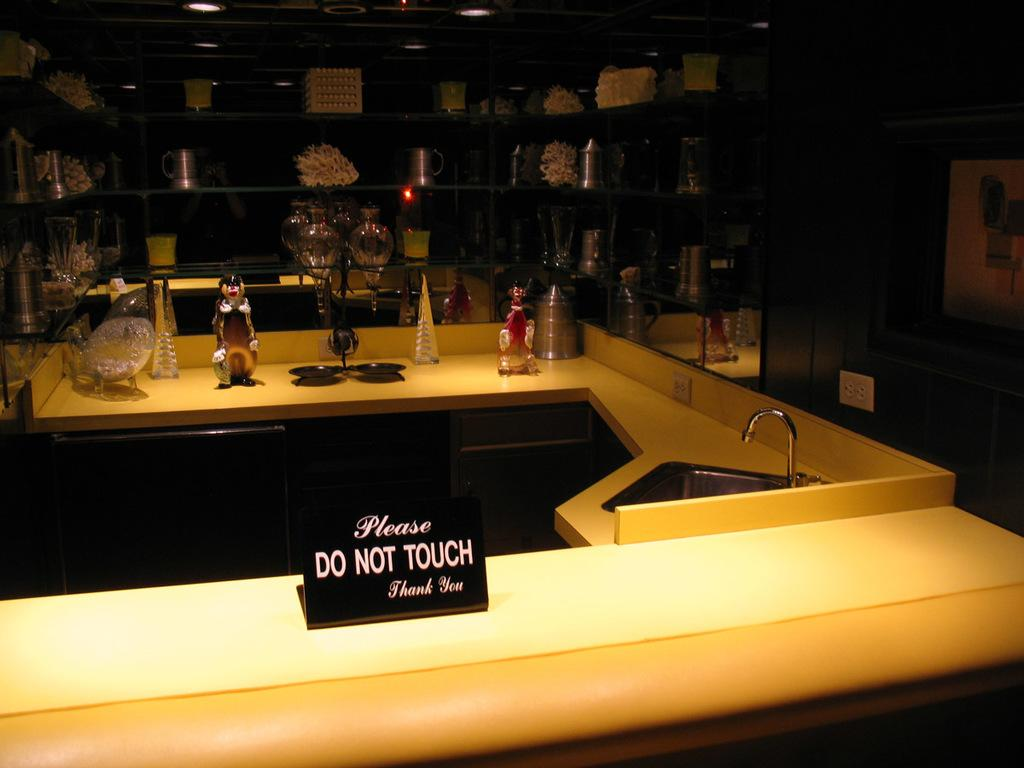What is the main object in the image? There is a basin in the image. What is located near the basin? There is a water tap in the image. What can be seen on the shelf in the image? There is a toy and other things on the shelf. What is the purpose of the message on the board? The message on the board says "please do not touch, thank you," which is likely meant to discourage touching the items on the shelf. How many stamps are on the toy in the image? There are no stamps visible on the toy in the image. Is there a stranger in the image? There is no mention of a stranger in the image, and no stranger is visible in the provided facts. 